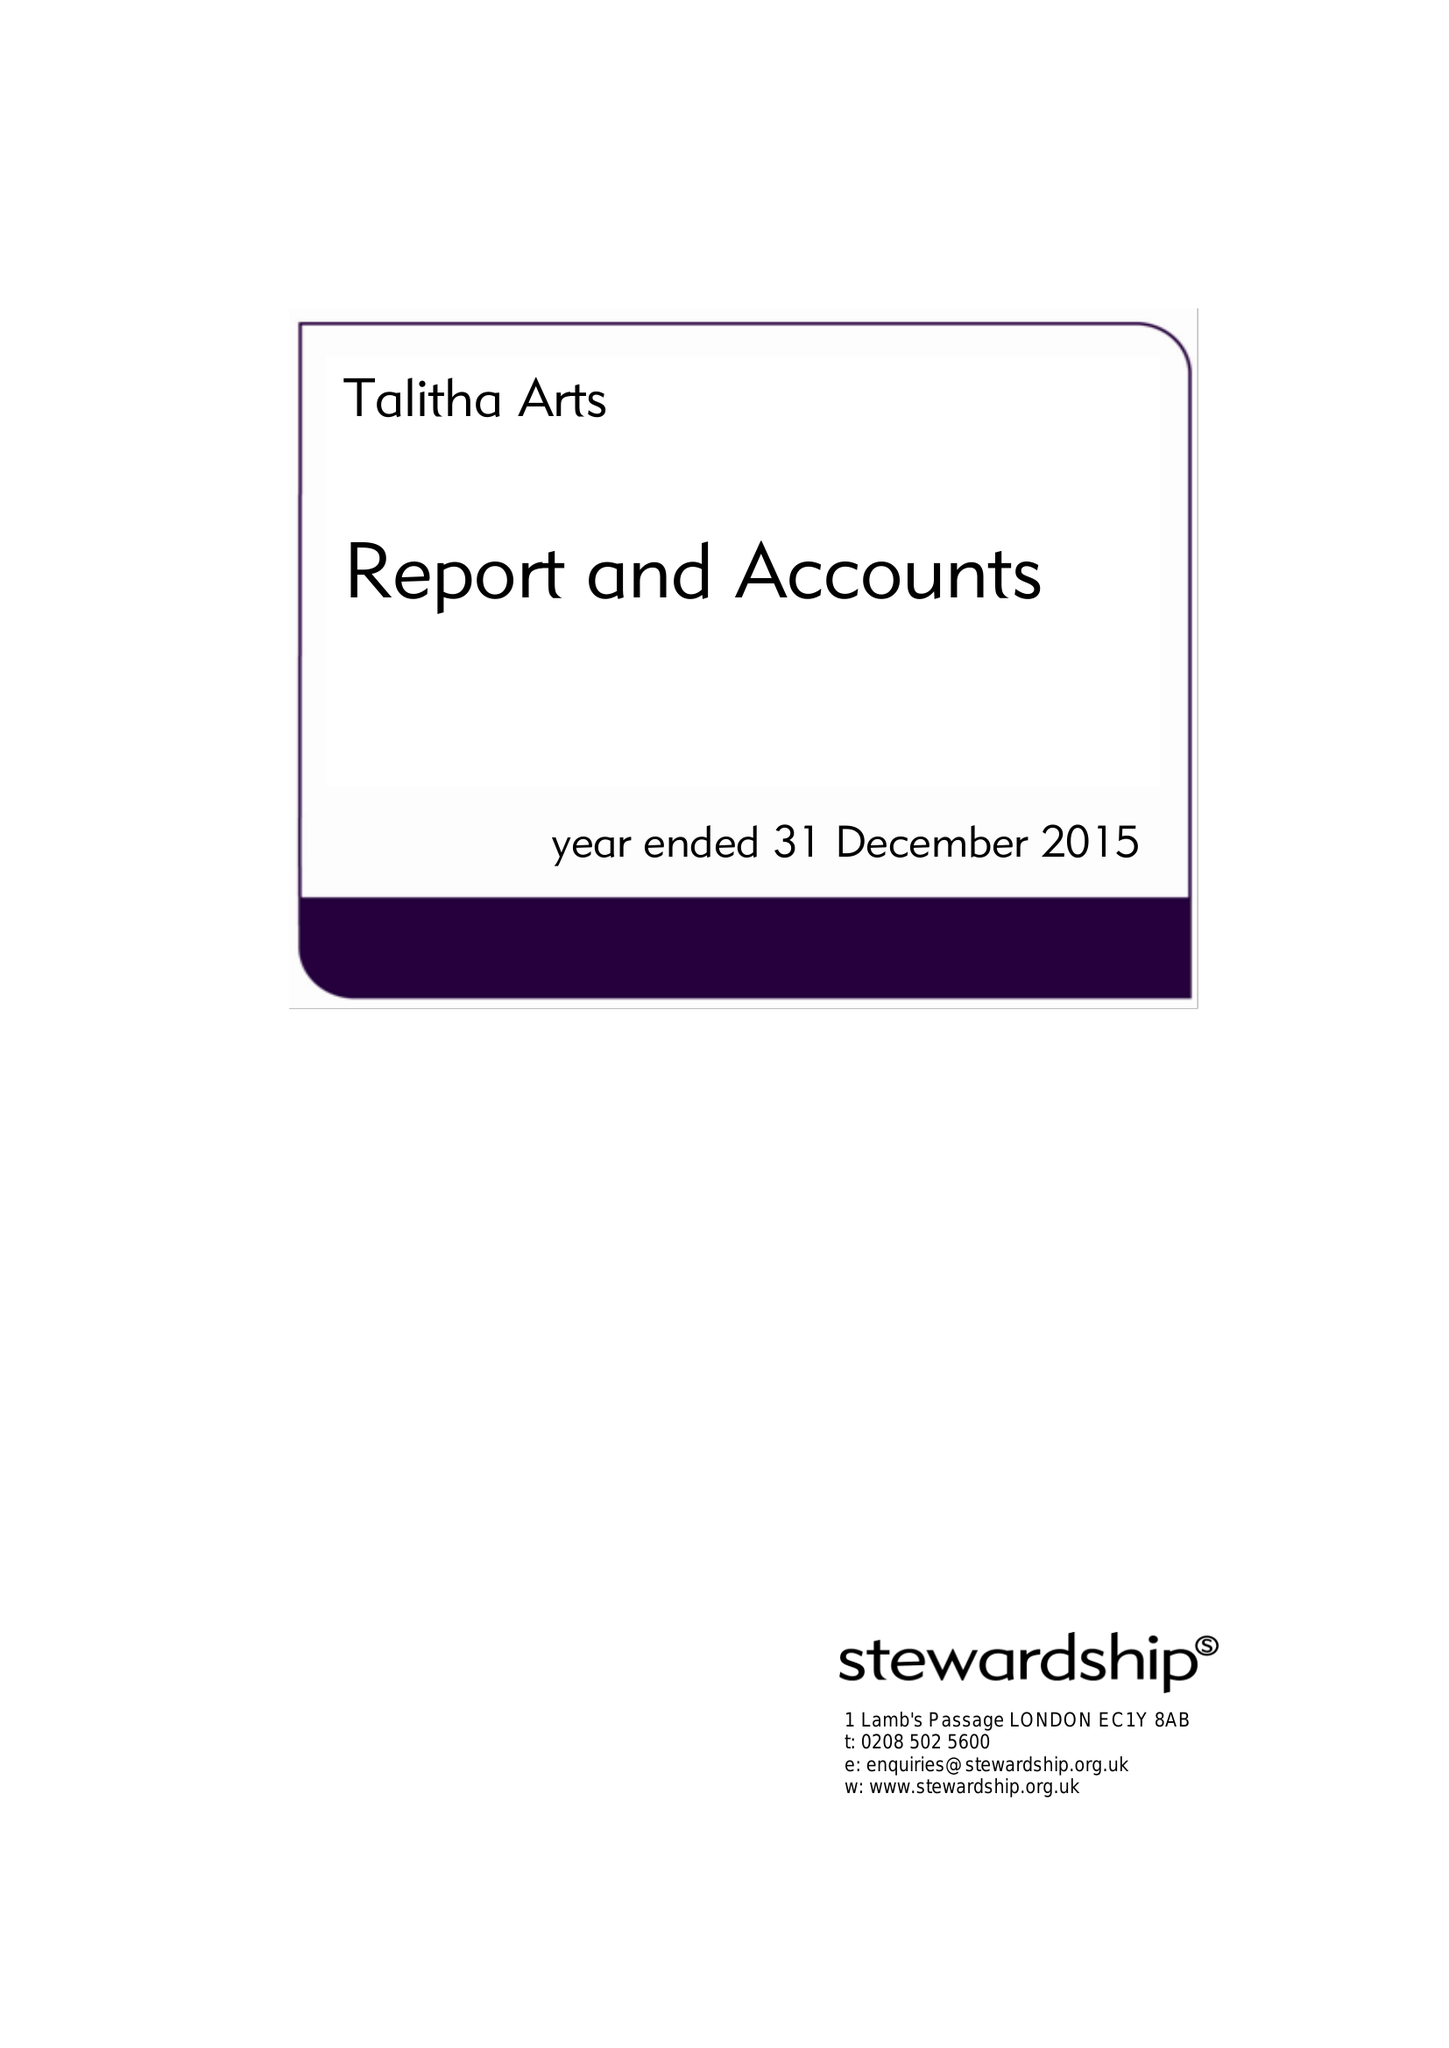What is the value for the income_annually_in_british_pounds?
Answer the question using a single word or phrase. 68240.00 